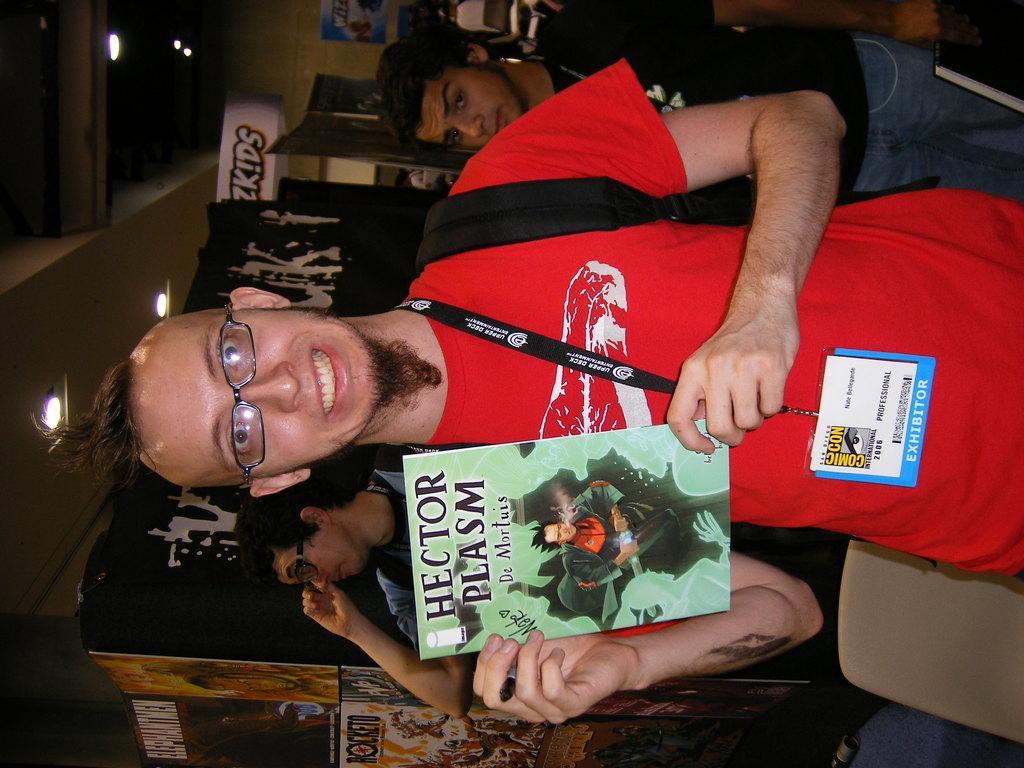How would you summarize this image in a sentence or two? This picture is in rightward direction. Towards the right, there is a man holding a book. He is wearing a red t shirt and ID card and he is also carrying a bag. On the top, there is another person wearing a black t shirt. At the bottom, there is a man. Towards the left, there is a roof with lights. 